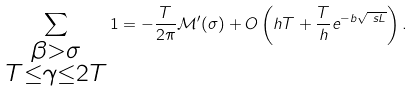<formula> <loc_0><loc_0><loc_500><loc_500>\sum _ { \substack { \beta > \sigma \\ T \leq \gamma \leq 2 T } } 1 & = - \frac { T } { 2 \pi } \mathcal { M } ^ { \prime } ( \sigma ) + O \left ( h T + \frac { T } { h } e ^ { - b \sqrt { \ s L } } \right ) .</formula> 